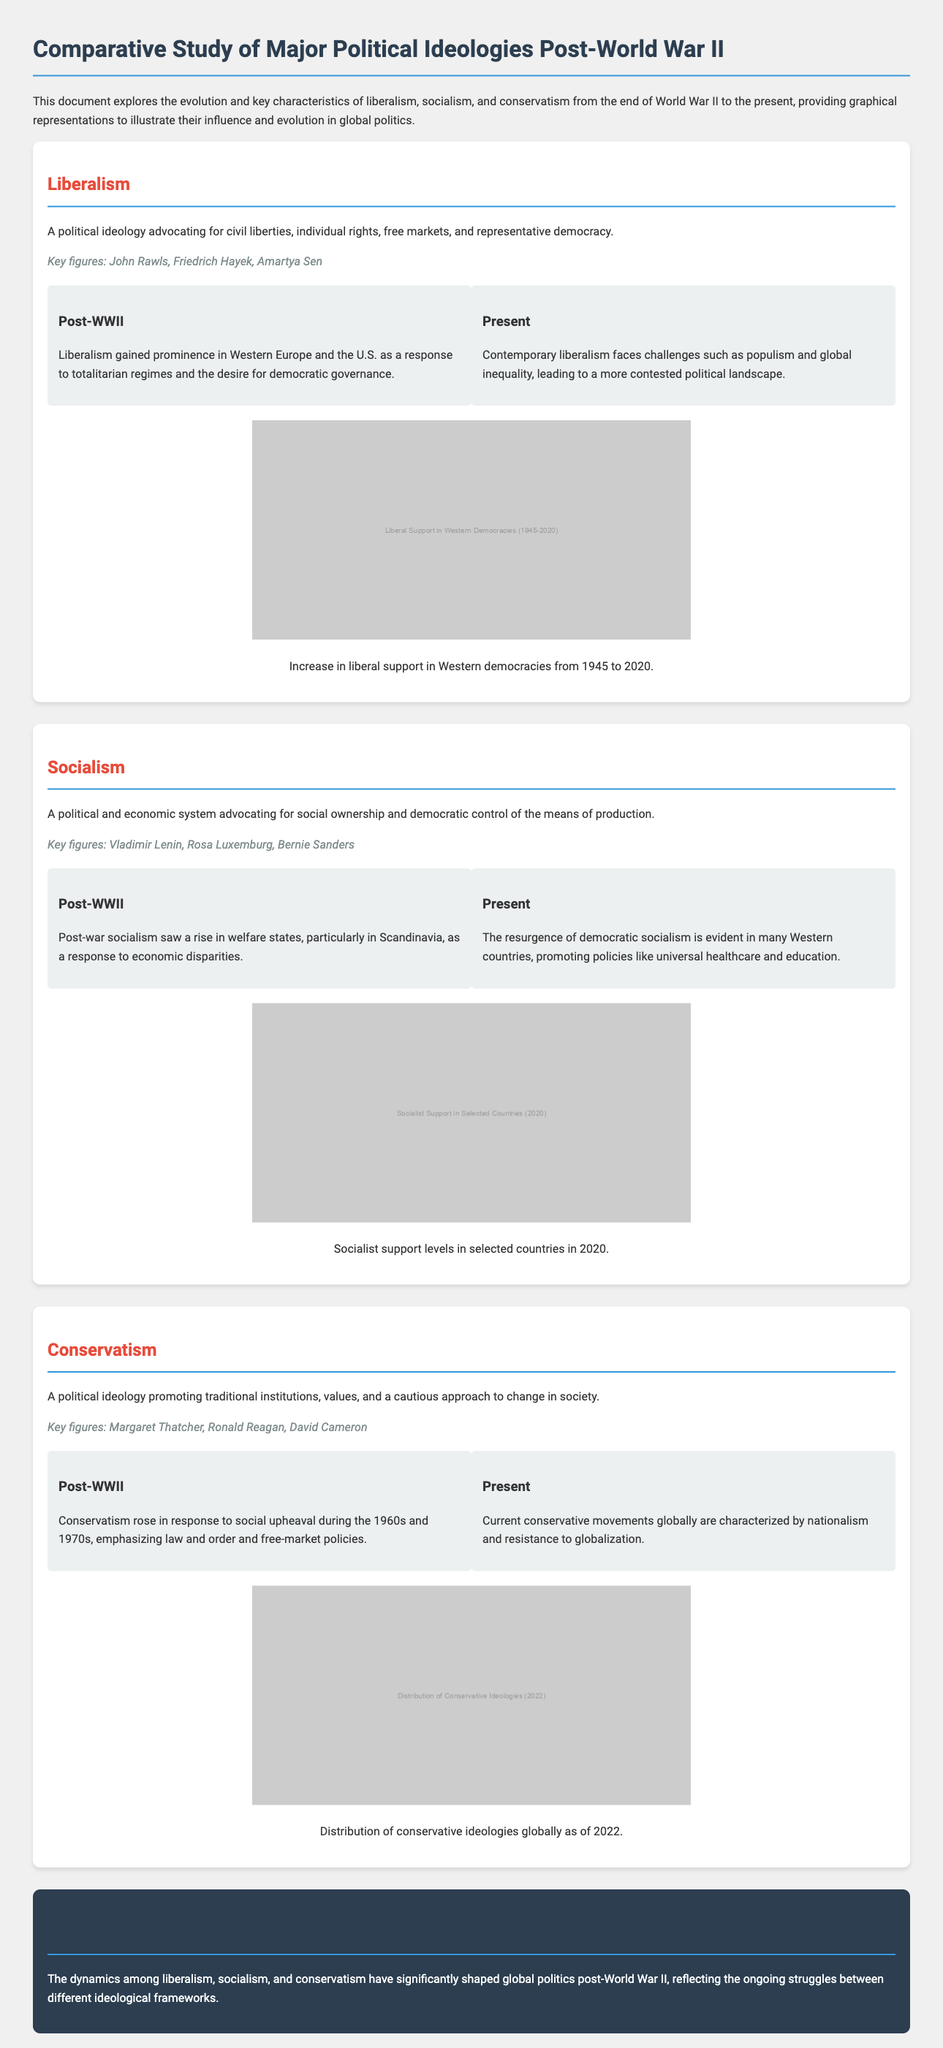What are the key figures associated with liberalism? The document lists John Rawls, Friedrich Hayek, and Amartya Sen as key figures of liberalism.
Answer: John Rawls, Friedrich Hayek, Amartya Sen What significant event marked the rise of socialism post-World War II? The document mentions the rise of welfare states in Scandinavia as a response to economic disparities.
Answer: Rise of welfare states What is the primary ideology that conservatism promotes? According to the document, conservatism promotes traditional institutions and values.
Answer: Traditional institutions and values Which ideology faces challenges due to populism and global inequality? The document indicates that contemporary liberalism faces challenges related to populism and global inequality.
Answer: Liberalism What year is indicated for socialist support levels in selected countries? The document specifies that the socialist support levels were measured in 2020.
Answer: 2020 What major political ideology is highlighted in the conclusion? The conclusion summarizes the dynamics of liberalism, socialism, and conservatism as significant to global politics.
Answer: Liberalism, socialism, conservatism What describes the contemporary conservative movements globally? The document characterizes current conservative movements as being marked by nationalism and resistance to globalization.
Answer: Nationalism and resistance to globalization What type of governance did liberalism promote post-WWII? Post-WWII, liberalism is described as advocating for democratic governance.
Answer: Democratic governance What graphical representation represents liberal support from 1945 to 2020? The document includes a graph titled "Liberal Support in Western Democracies (1945-2020)" to illustrate this.
Answer: Liberal Support in Western Democracies (1945-2020) 